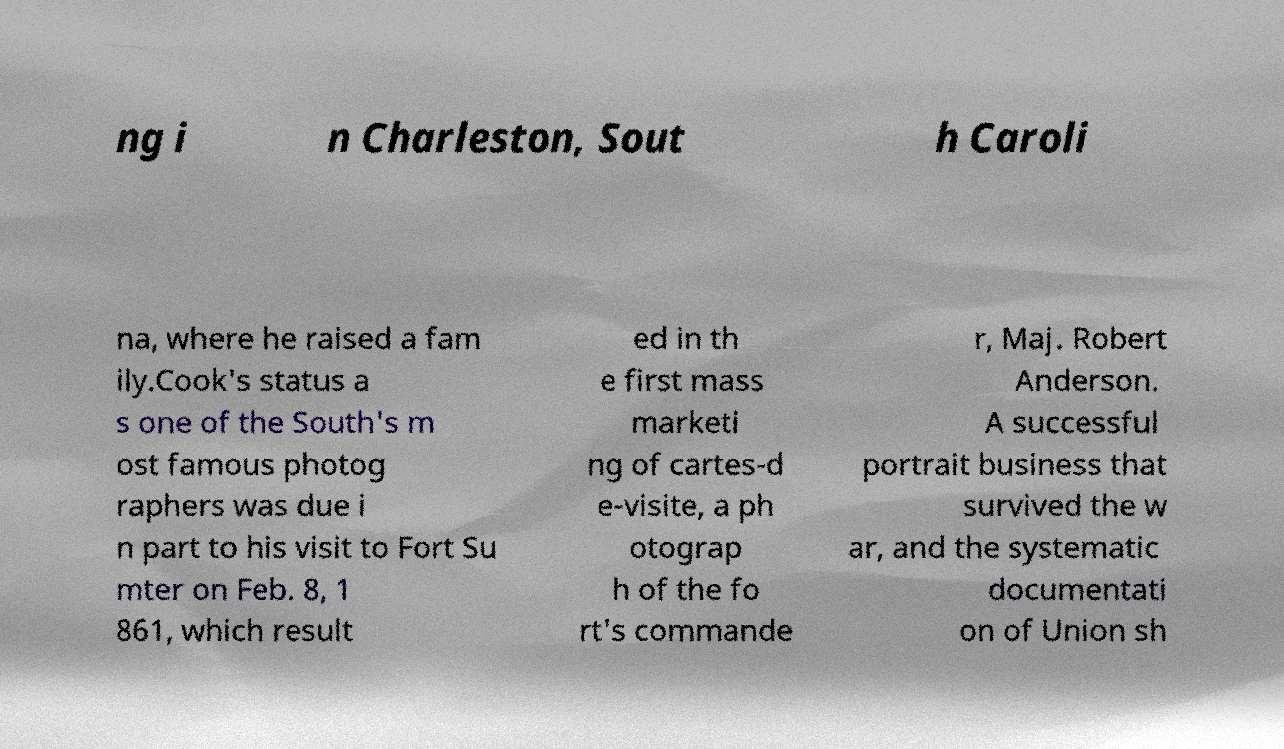For documentation purposes, I need the text within this image transcribed. Could you provide that? ng i n Charleston, Sout h Caroli na, where he raised a fam ily.Cook's status a s one of the South's m ost famous photog raphers was due i n part to his visit to Fort Su mter on Feb. 8, 1 861, which result ed in th e first mass marketi ng of cartes-d e-visite, a ph otograp h of the fo rt's commande r, Maj. Robert Anderson. A successful portrait business that survived the w ar, and the systematic documentati on of Union sh 